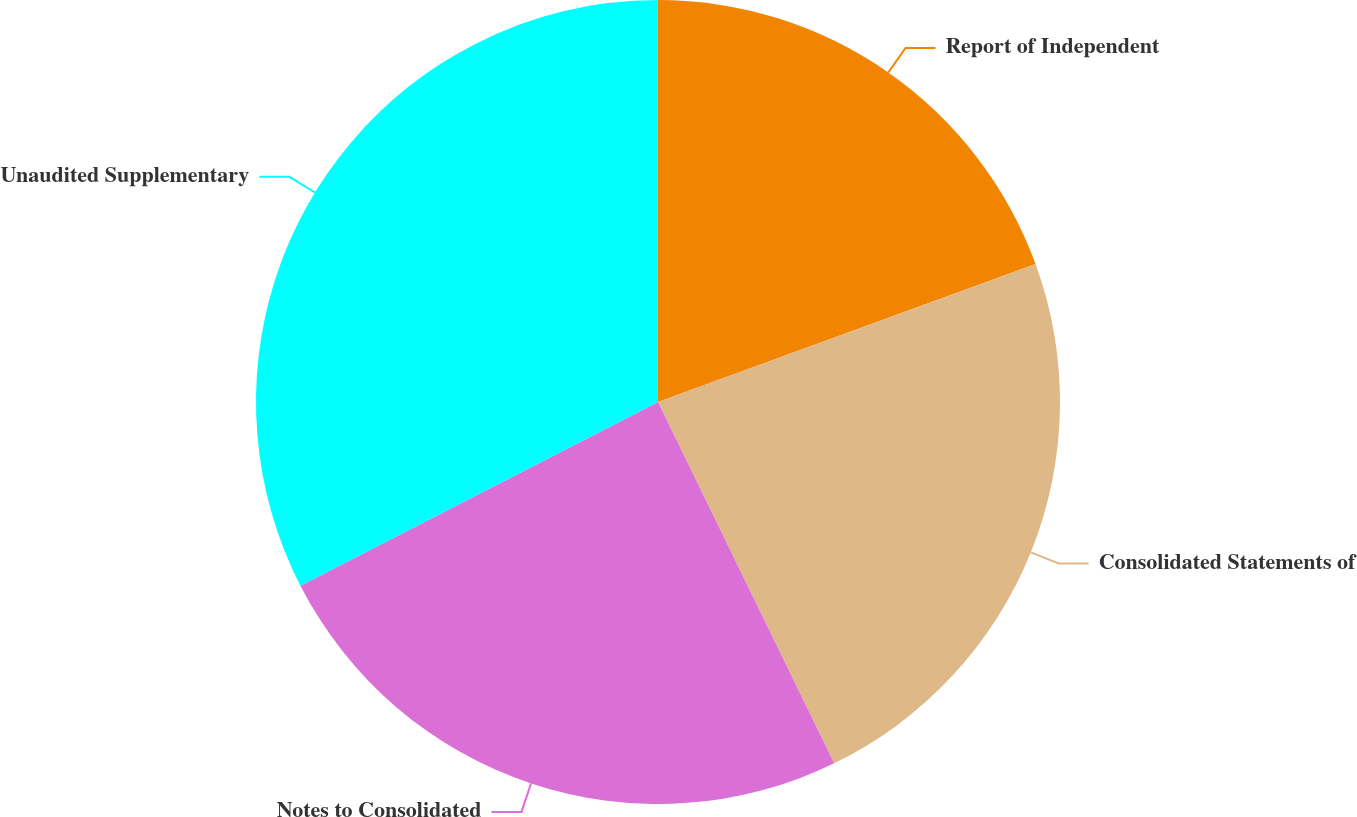Convert chart. <chart><loc_0><loc_0><loc_500><loc_500><pie_chart><fcel>Report of Independent<fcel>Consolidated Statements of<fcel>Notes to Consolidated<fcel>Unaudited Supplementary<nl><fcel>19.42%<fcel>23.36%<fcel>24.67%<fcel>32.55%<nl></chart> 